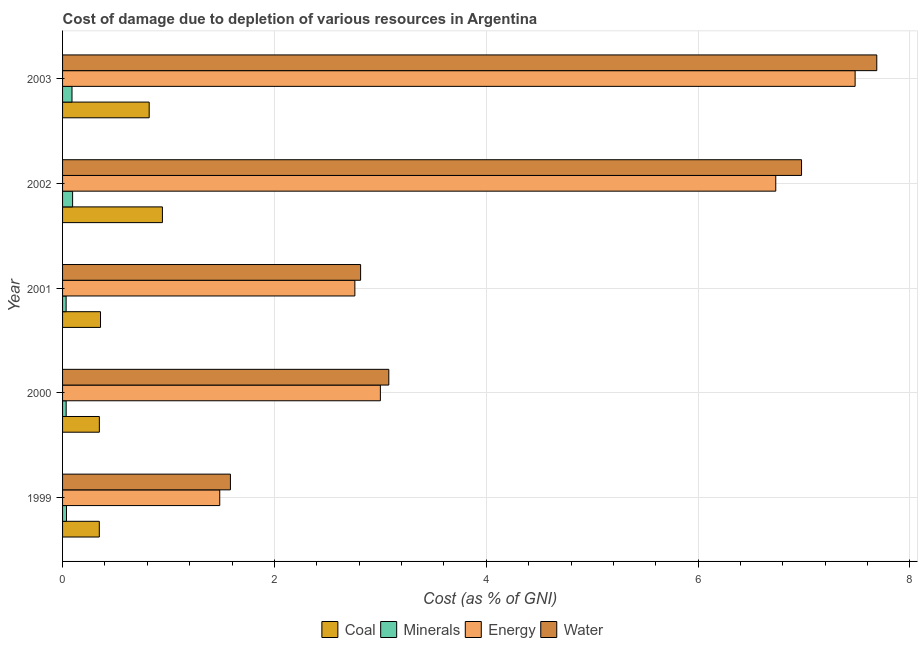How many different coloured bars are there?
Provide a succinct answer. 4. Are the number of bars per tick equal to the number of legend labels?
Provide a succinct answer. Yes. Are the number of bars on each tick of the Y-axis equal?
Ensure brevity in your answer.  Yes. What is the label of the 4th group of bars from the top?
Make the answer very short. 2000. In how many cases, is the number of bars for a given year not equal to the number of legend labels?
Your response must be concise. 0. What is the cost of damage due to depletion of coal in 2003?
Give a very brief answer. 0.82. Across all years, what is the maximum cost of damage due to depletion of water?
Offer a terse response. 7.69. Across all years, what is the minimum cost of damage due to depletion of energy?
Offer a terse response. 1.48. What is the total cost of damage due to depletion of water in the graph?
Provide a succinct answer. 22.14. What is the difference between the cost of damage due to depletion of coal in 1999 and that in 2000?
Your answer should be compact. -0. What is the difference between the cost of damage due to depletion of water in 1999 and the cost of damage due to depletion of energy in 2001?
Ensure brevity in your answer.  -1.17. What is the average cost of damage due to depletion of coal per year?
Make the answer very short. 0.56. In the year 2000, what is the difference between the cost of damage due to depletion of minerals and cost of damage due to depletion of energy?
Offer a terse response. -2.97. What is the ratio of the cost of damage due to depletion of energy in 2001 to that in 2002?
Your answer should be very brief. 0.41. Is the cost of damage due to depletion of energy in 1999 less than that in 2002?
Your answer should be compact. Yes. Is the difference between the cost of damage due to depletion of energy in 2000 and 2001 greater than the difference between the cost of damage due to depletion of minerals in 2000 and 2001?
Provide a succinct answer. Yes. What is the difference between the highest and the second highest cost of damage due to depletion of water?
Give a very brief answer. 0.71. In how many years, is the cost of damage due to depletion of coal greater than the average cost of damage due to depletion of coal taken over all years?
Ensure brevity in your answer.  2. Is it the case that in every year, the sum of the cost of damage due to depletion of water and cost of damage due to depletion of coal is greater than the sum of cost of damage due to depletion of minerals and cost of damage due to depletion of energy?
Provide a succinct answer. Yes. What does the 3rd bar from the top in 1999 represents?
Your answer should be compact. Minerals. What does the 3rd bar from the bottom in 2002 represents?
Your answer should be very brief. Energy. Is it the case that in every year, the sum of the cost of damage due to depletion of coal and cost of damage due to depletion of minerals is greater than the cost of damage due to depletion of energy?
Your response must be concise. No. How many bars are there?
Your response must be concise. 20. Are all the bars in the graph horizontal?
Keep it short and to the point. Yes. Does the graph contain grids?
Your response must be concise. Yes. Where does the legend appear in the graph?
Your answer should be compact. Bottom center. How are the legend labels stacked?
Offer a very short reply. Horizontal. What is the title of the graph?
Ensure brevity in your answer.  Cost of damage due to depletion of various resources in Argentina . What is the label or title of the X-axis?
Offer a terse response. Cost (as % of GNI). What is the Cost (as % of GNI) of Coal in 1999?
Your response must be concise. 0.35. What is the Cost (as % of GNI) of Minerals in 1999?
Keep it short and to the point. 0.04. What is the Cost (as % of GNI) of Energy in 1999?
Provide a succinct answer. 1.48. What is the Cost (as % of GNI) of Water in 1999?
Offer a terse response. 1.58. What is the Cost (as % of GNI) of Coal in 2000?
Offer a terse response. 0.35. What is the Cost (as % of GNI) in Minerals in 2000?
Provide a succinct answer. 0.03. What is the Cost (as % of GNI) of Energy in 2000?
Keep it short and to the point. 3. What is the Cost (as % of GNI) in Water in 2000?
Your answer should be compact. 3.08. What is the Cost (as % of GNI) of Coal in 2001?
Your response must be concise. 0.36. What is the Cost (as % of GNI) in Minerals in 2001?
Offer a very short reply. 0.03. What is the Cost (as % of GNI) in Energy in 2001?
Keep it short and to the point. 2.76. What is the Cost (as % of GNI) of Water in 2001?
Provide a short and direct response. 2.81. What is the Cost (as % of GNI) in Coal in 2002?
Keep it short and to the point. 0.94. What is the Cost (as % of GNI) in Minerals in 2002?
Your answer should be compact. 0.09. What is the Cost (as % of GNI) of Energy in 2002?
Provide a short and direct response. 6.73. What is the Cost (as % of GNI) in Water in 2002?
Your response must be concise. 6.98. What is the Cost (as % of GNI) of Coal in 2003?
Your answer should be very brief. 0.82. What is the Cost (as % of GNI) of Minerals in 2003?
Ensure brevity in your answer.  0.09. What is the Cost (as % of GNI) in Energy in 2003?
Your answer should be very brief. 7.48. What is the Cost (as % of GNI) of Water in 2003?
Make the answer very short. 7.69. Across all years, what is the maximum Cost (as % of GNI) in Coal?
Your answer should be compact. 0.94. Across all years, what is the maximum Cost (as % of GNI) of Minerals?
Provide a short and direct response. 0.09. Across all years, what is the maximum Cost (as % of GNI) of Energy?
Provide a short and direct response. 7.48. Across all years, what is the maximum Cost (as % of GNI) in Water?
Give a very brief answer. 7.69. Across all years, what is the minimum Cost (as % of GNI) in Coal?
Give a very brief answer. 0.35. Across all years, what is the minimum Cost (as % of GNI) of Minerals?
Make the answer very short. 0.03. Across all years, what is the minimum Cost (as % of GNI) in Energy?
Ensure brevity in your answer.  1.48. Across all years, what is the minimum Cost (as % of GNI) in Water?
Offer a terse response. 1.58. What is the total Cost (as % of GNI) in Coal in the graph?
Provide a succinct answer. 2.81. What is the total Cost (as % of GNI) of Minerals in the graph?
Offer a very short reply. 0.29. What is the total Cost (as % of GNI) in Energy in the graph?
Ensure brevity in your answer.  21.46. What is the total Cost (as % of GNI) in Water in the graph?
Ensure brevity in your answer.  22.14. What is the difference between the Cost (as % of GNI) of Coal in 1999 and that in 2000?
Make the answer very short. -0. What is the difference between the Cost (as % of GNI) in Minerals in 1999 and that in 2000?
Your answer should be very brief. 0. What is the difference between the Cost (as % of GNI) of Energy in 1999 and that in 2000?
Provide a succinct answer. -1.52. What is the difference between the Cost (as % of GNI) in Water in 1999 and that in 2000?
Your response must be concise. -1.5. What is the difference between the Cost (as % of GNI) in Coal in 1999 and that in 2001?
Provide a succinct answer. -0.01. What is the difference between the Cost (as % of GNI) of Minerals in 1999 and that in 2001?
Offer a very short reply. 0. What is the difference between the Cost (as % of GNI) of Energy in 1999 and that in 2001?
Keep it short and to the point. -1.28. What is the difference between the Cost (as % of GNI) in Water in 1999 and that in 2001?
Provide a short and direct response. -1.23. What is the difference between the Cost (as % of GNI) of Coal in 1999 and that in 2002?
Your answer should be compact. -0.6. What is the difference between the Cost (as % of GNI) of Minerals in 1999 and that in 2002?
Give a very brief answer. -0.06. What is the difference between the Cost (as % of GNI) in Energy in 1999 and that in 2002?
Provide a succinct answer. -5.25. What is the difference between the Cost (as % of GNI) of Water in 1999 and that in 2002?
Ensure brevity in your answer.  -5.39. What is the difference between the Cost (as % of GNI) in Coal in 1999 and that in 2003?
Your answer should be very brief. -0.47. What is the difference between the Cost (as % of GNI) in Minerals in 1999 and that in 2003?
Offer a terse response. -0.05. What is the difference between the Cost (as % of GNI) of Energy in 1999 and that in 2003?
Your response must be concise. -6. What is the difference between the Cost (as % of GNI) in Water in 1999 and that in 2003?
Offer a terse response. -6.1. What is the difference between the Cost (as % of GNI) of Coal in 2000 and that in 2001?
Provide a short and direct response. -0.01. What is the difference between the Cost (as % of GNI) of Minerals in 2000 and that in 2001?
Provide a short and direct response. 0. What is the difference between the Cost (as % of GNI) of Energy in 2000 and that in 2001?
Provide a short and direct response. 0.24. What is the difference between the Cost (as % of GNI) in Water in 2000 and that in 2001?
Provide a succinct answer. 0.27. What is the difference between the Cost (as % of GNI) of Coal in 2000 and that in 2002?
Your answer should be very brief. -0.6. What is the difference between the Cost (as % of GNI) in Minerals in 2000 and that in 2002?
Offer a terse response. -0.06. What is the difference between the Cost (as % of GNI) in Energy in 2000 and that in 2002?
Keep it short and to the point. -3.73. What is the difference between the Cost (as % of GNI) in Water in 2000 and that in 2002?
Ensure brevity in your answer.  -3.9. What is the difference between the Cost (as % of GNI) in Coal in 2000 and that in 2003?
Your answer should be compact. -0.47. What is the difference between the Cost (as % of GNI) of Minerals in 2000 and that in 2003?
Make the answer very short. -0.06. What is the difference between the Cost (as % of GNI) in Energy in 2000 and that in 2003?
Make the answer very short. -4.48. What is the difference between the Cost (as % of GNI) of Water in 2000 and that in 2003?
Offer a terse response. -4.61. What is the difference between the Cost (as % of GNI) in Coal in 2001 and that in 2002?
Make the answer very short. -0.58. What is the difference between the Cost (as % of GNI) of Minerals in 2001 and that in 2002?
Keep it short and to the point. -0.06. What is the difference between the Cost (as % of GNI) in Energy in 2001 and that in 2002?
Provide a succinct answer. -3.97. What is the difference between the Cost (as % of GNI) of Water in 2001 and that in 2002?
Your response must be concise. -4.16. What is the difference between the Cost (as % of GNI) in Coal in 2001 and that in 2003?
Keep it short and to the point. -0.46. What is the difference between the Cost (as % of GNI) of Minerals in 2001 and that in 2003?
Your answer should be compact. -0.06. What is the difference between the Cost (as % of GNI) of Energy in 2001 and that in 2003?
Your response must be concise. -4.72. What is the difference between the Cost (as % of GNI) in Water in 2001 and that in 2003?
Your answer should be compact. -4.87. What is the difference between the Cost (as % of GNI) of Coal in 2002 and that in 2003?
Your answer should be very brief. 0.12. What is the difference between the Cost (as % of GNI) in Minerals in 2002 and that in 2003?
Offer a terse response. 0.01. What is the difference between the Cost (as % of GNI) in Energy in 2002 and that in 2003?
Make the answer very short. -0.75. What is the difference between the Cost (as % of GNI) of Water in 2002 and that in 2003?
Ensure brevity in your answer.  -0.71. What is the difference between the Cost (as % of GNI) of Coal in 1999 and the Cost (as % of GNI) of Minerals in 2000?
Offer a very short reply. 0.31. What is the difference between the Cost (as % of GNI) of Coal in 1999 and the Cost (as % of GNI) of Energy in 2000?
Your answer should be very brief. -2.65. What is the difference between the Cost (as % of GNI) of Coal in 1999 and the Cost (as % of GNI) of Water in 2000?
Your answer should be compact. -2.73. What is the difference between the Cost (as % of GNI) of Minerals in 1999 and the Cost (as % of GNI) of Energy in 2000?
Offer a very short reply. -2.96. What is the difference between the Cost (as % of GNI) in Minerals in 1999 and the Cost (as % of GNI) in Water in 2000?
Give a very brief answer. -3.04. What is the difference between the Cost (as % of GNI) of Energy in 1999 and the Cost (as % of GNI) of Water in 2000?
Ensure brevity in your answer.  -1.6. What is the difference between the Cost (as % of GNI) of Coal in 1999 and the Cost (as % of GNI) of Minerals in 2001?
Keep it short and to the point. 0.31. What is the difference between the Cost (as % of GNI) in Coal in 1999 and the Cost (as % of GNI) in Energy in 2001?
Your answer should be compact. -2.41. What is the difference between the Cost (as % of GNI) of Coal in 1999 and the Cost (as % of GNI) of Water in 2001?
Ensure brevity in your answer.  -2.47. What is the difference between the Cost (as % of GNI) of Minerals in 1999 and the Cost (as % of GNI) of Energy in 2001?
Your answer should be compact. -2.72. What is the difference between the Cost (as % of GNI) of Minerals in 1999 and the Cost (as % of GNI) of Water in 2001?
Offer a very short reply. -2.78. What is the difference between the Cost (as % of GNI) of Energy in 1999 and the Cost (as % of GNI) of Water in 2001?
Offer a terse response. -1.33. What is the difference between the Cost (as % of GNI) of Coal in 1999 and the Cost (as % of GNI) of Minerals in 2002?
Provide a short and direct response. 0.25. What is the difference between the Cost (as % of GNI) of Coal in 1999 and the Cost (as % of GNI) of Energy in 2002?
Your response must be concise. -6.39. What is the difference between the Cost (as % of GNI) of Coal in 1999 and the Cost (as % of GNI) of Water in 2002?
Provide a succinct answer. -6.63. What is the difference between the Cost (as % of GNI) of Minerals in 1999 and the Cost (as % of GNI) of Energy in 2002?
Ensure brevity in your answer.  -6.7. What is the difference between the Cost (as % of GNI) of Minerals in 1999 and the Cost (as % of GNI) of Water in 2002?
Your answer should be compact. -6.94. What is the difference between the Cost (as % of GNI) of Energy in 1999 and the Cost (as % of GNI) of Water in 2002?
Provide a short and direct response. -5.49. What is the difference between the Cost (as % of GNI) of Coal in 1999 and the Cost (as % of GNI) of Minerals in 2003?
Offer a very short reply. 0.26. What is the difference between the Cost (as % of GNI) of Coal in 1999 and the Cost (as % of GNI) of Energy in 2003?
Keep it short and to the point. -7.14. What is the difference between the Cost (as % of GNI) of Coal in 1999 and the Cost (as % of GNI) of Water in 2003?
Offer a very short reply. -7.34. What is the difference between the Cost (as % of GNI) in Minerals in 1999 and the Cost (as % of GNI) in Energy in 2003?
Offer a very short reply. -7.44. What is the difference between the Cost (as % of GNI) in Minerals in 1999 and the Cost (as % of GNI) in Water in 2003?
Offer a very short reply. -7.65. What is the difference between the Cost (as % of GNI) of Energy in 1999 and the Cost (as % of GNI) of Water in 2003?
Your answer should be very brief. -6.2. What is the difference between the Cost (as % of GNI) of Coal in 2000 and the Cost (as % of GNI) of Minerals in 2001?
Provide a short and direct response. 0.31. What is the difference between the Cost (as % of GNI) in Coal in 2000 and the Cost (as % of GNI) in Energy in 2001?
Make the answer very short. -2.41. What is the difference between the Cost (as % of GNI) in Coal in 2000 and the Cost (as % of GNI) in Water in 2001?
Ensure brevity in your answer.  -2.47. What is the difference between the Cost (as % of GNI) in Minerals in 2000 and the Cost (as % of GNI) in Energy in 2001?
Your answer should be compact. -2.73. What is the difference between the Cost (as % of GNI) in Minerals in 2000 and the Cost (as % of GNI) in Water in 2001?
Offer a terse response. -2.78. What is the difference between the Cost (as % of GNI) of Energy in 2000 and the Cost (as % of GNI) of Water in 2001?
Provide a short and direct response. 0.19. What is the difference between the Cost (as % of GNI) of Coal in 2000 and the Cost (as % of GNI) of Minerals in 2002?
Your answer should be compact. 0.25. What is the difference between the Cost (as % of GNI) in Coal in 2000 and the Cost (as % of GNI) in Energy in 2002?
Keep it short and to the point. -6.39. What is the difference between the Cost (as % of GNI) in Coal in 2000 and the Cost (as % of GNI) in Water in 2002?
Offer a terse response. -6.63. What is the difference between the Cost (as % of GNI) in Minerals in 2000 and the Cost (as % of GNI) in Energy in 2002?
Keep it short and to the point. -6.7. What is the difference between the Cost (as % of GNI) of Minerals in 2000 and the Cost (as % of GNI) of Water in 2002?
Make the answer very short. -6.94. What is the difference between the Cost (as % of GNI) of Energy in 2000 and the Cost (as % of GNI) of Water in 2002?
Ensure brevity in your answer.  -3.98. What is the difference between the Cost (as % of GNI) of Coal in 2000 and the Cost (as % of GNI) of Minerals in 2003?
Provide a short and direct response. 0.26. What is the difference between the Cost (as % of GNI) in Coal in 2000 and the Cost (as % of GNI) in Energy in 2003?
Ensure brevity in your answer.  -7.13. What is the difference between the Cost (as % of GNI) in Coal in 2000 and the Cost (as % of GNI) in Water in 2003?
Offer a terse response. -7.34. What is the difference between the Cost (as % of GNI) in Minerals in 2000 and the Cost (as % of GNI) in Energy in 2003?
Provide a succinct answer. -7.45. What is the difference between the Cost (as % of GNI) of Minerals in 2000 and the Cost (as % of GNI) of Water in 2003?
Offer a very short reply. -7.65. What is the difference between the Cost (as % of GNI) of Energy in 2000 and the Cost (as % of GNI) of Water in 2003?
Provide a succinct answer. -4.69. What is the difference between the Cost (as % of GNI) of Coal in 2001 and the Cost (as % of GNI) of Minerals in 2002?
Your answer should be compact. 0.26. What is the difference between the Cost (as % of GNI) of Coal in 2001 and the Cost (as % of GNI) of Energy in 2002?
Offer a very short reply. -6.37. What is the difference between the Cost (as % of GNI) of Coal in 2001 and the Cost (as % of GNI) of Water in 2002?
Make the answer very short. -6.62. What is the difference between the Cost (as % of GNI) of Minerals in 2001 and the Cost (as % of GNI) of Energy in 2002?
Your response must be concise. -6.7. What is the difference between the Cost (as % of GNI) in Minerals in 2001 and the Cost (as % of GNI) in Water in 2002?
Offer a terse response. -6.94. What is the difference between the Cost (as % of GNI) in Energy in 2001 and the Cost (as % of GNI) in Water in 2002?
Offer a terse response. -4.22. What is the difference between the Cost (as % of GNI) of Coal in 2001 and the Cost (as % of GNI) of Minerals in 2003?
Your answer should be very brief. 0.27. What is the difference between the Cost (as % of GNI) of Coal in 2001 and the Cost (as % of GNI) of Energy in 2003?
Ensure brevity in your answer.  -7.12. What is the difference between the Cost (as % of GNI) of Coal in 2001 and the Cost (as % of GNI) of Water in 2003?
Make the answer very short. -7.33. What is the difference between the Cost (as % of GNI) in Minerals in 2001 and the Cost (as % of GNI) in Energy in 2003?
Offer a terse response. -7.45. What is the difference between the Cost (as % of GNI) in Minerals in 2001 and the Cost (as % of GNI) in Water in 2003?
Your response must be concise. -7.65. What is the difference between the Cost (as % of GNI) of Energy in 2001 and the Cost (as % of GNI) of Water in 2003?
Give a very brief answer. -4.93. What is the difference between the Cost (as % of GNI) in Coal in 2002 and the Cost (as % of GNI) in Minerals in 2003?
Provide a succinct answer. 0.85. What is the difference between the Cost (as % of GNI) in Coal in 2002 and the Cost (as % of GNI) in Energy in 2003?
Offer a very short reply. -6.54. What is the difference between the Cost (as % of GNI) of Coal in 2002 and the Cost (as % of GNI) of Water in 2003?
Your answer should be compact. -6.74. What is the difference between the Cost (as % of GNI) of Minerals in 2002 and the Cost (as % of GNI) of Energy in 2003?
Offer a terse response. -7.39. What is the difference between the Cost (as % of GNI) of Minerals in 2002 and the Cost (as % of GNI) of Water in 2003?
Ensure brevity in your answer.  -7.59. What is the difference between the Cost (as % of GNI) in Energy in 2002 and the Cost (as % of GNI) in Water in 2003?
Your answer should be very brief. -0.95. What is the average Cost (as % of GNI) in Coal per year?
Provide a short and direct response. 0.56. What is the average Cost (as % of GNI) of Minerals per year?
Keep it short and to the point. 0.06. What is the average Cost (as % of GNI) of Energy per year?
Give a very brief answer. 4.29. What is the average Cost (as % of GNI) of Water per year?
Your answer should be very brief. 4.43. In the year 1999, what is the difference between the Cost (as % of GNI) of Coal and Cost (as % of GNI) of Minerals?
Offer a terse response. 0.31. In the year 1999, what is the difference between the Cost (as % of GNI) in Coal and Cost (as % of GNI) in Energy?
Your answer should be very brief. -1.14. In the year 1999, what is the difference between the Cost (as % of GNI) of Coal and Cost (as % of GNI) of Water?
Give a very brief answer. -1.24. In the year 1999, what is the difference between the Cost (as % of GNI) of Minerals and Cost (as % of GNI) of Energy?
Your response must be concise. -1.45. In the year 1999, what is the difference between the Cost (as % of GNI) of Minerals and Cost (as % of GNI) of Water?
Offer a very short reply. -1.55. In the year 1999, what is the difference between the Cost (as % of GNI) of Energy and Cost (as % of GNI) of Water?
Your answer should be very brief. -0.1. In the year 2000, what is the difference between the Cost (as % of GNI) in Coal and Cost (as % of GNI) in Minerals?
Provide a succinct answer. 0.31. In the year 2000, what is the difference between the Cost (as % of GNI) of Coal and Cost (as % of GNI) of Energy?
Ensure brevity in your answer.  -2.65. In the year 2000, what is the difference between the Cost (as % of GNI) of Coal and Cost (as % of GNI) of Water?
Provide a succinct answer. -2.73. In the year 2000, what is the difference between the Cost (as % of GNI) of Minerals and Cost (as % of GNI) of Energy?
Make the answer very short. -2.97. In the year 2000, what is the difference between the Cost (as % of GNI) of Minerals and Cost (as % of GNI) of Water?
Your answer should be very brief. -3.05. In the year 2000, what is the difference between the Cost (as % of GNI) of Energy and Cost (as % of GNI) of Water?
Your answer should be very brief. -0.08. In the year 2001, what is the difference between the Cost (as % of GNI) in Coal and Cost (as % of GNI) in Minerals?
Provide a short and direct response. 0.32. In the year 2001, what is the difference between the Cost (as % of GNI) of Coal and Cost (as % of GNI) of Energy?
Ensure brevity in your answer.  -2.4. In the year 2001, what is the difference between the Cost (as % of GNI) in Coal and Cost (as % of GNI) in Water?
Give a very brief answer. -2.46. In the year 2001, what is the difference between the Cost (as % of GNI) of Minerals and Cost (as % of GNI) of Energy?
Provide a succinct answer. -2.73. In the year 2001, what is the difference between the Cost (as % of GNI) of Minerals and Cost (as % of GNI) of Water?
Your answer should be very brief. -2.78. In the year 2001, what is the difference between the Cost (as % of GNI) in Energy and Cost (as % of GNI) in Water?
Make the answer very short. -0.05. In the year 2002, what is the difference between the Cost (as % of GNI) of Coal and Cost (as % of GNI) of Minerals?
Make the answer very short. 0.85. In the year 2002, what is the difference between the Cost (as % of GNI) in Coal and Cost (as % of GNI) in Energy?
Offer a terse response. -5.79. In the year 2002, what is the difference between the Cost (as % of GNI) in Coal and Cost (as % of GNI) in Water?
Offer a very short reply. -6.03. In the year 2002, what is the difference between the Cost (as % of GNI) of Minerals and Cost (as % of GNI) of Energy?
Offer a very short reply. -6.64. In the year 2002, what is the difference between the Cost (as % of GNI) in Minerals and Cost (as % of GNI) in Water?
Keep it short and to the point. -6.88. In the year 2002, what is the difference between the Cost (as % of GNI) of Energy and Cost (as % of GNI) of Water?
Your answer should be very brief. -0.24. In the year 2003, what is the difference between the Cost (as % of GNI) of Coal and Cost (as % of GNI) of Minerals?
Offer a terse response. 0.73. In the year 2003, what is the difference between the Cost (as % of GNI) of Coal and Cost (as % of GNI) of Energy?
Offer a very short reply. -6.66. In the year 2003, what is the difference between the Cost (as % of GNI) of Coal and Cost (as % of GNI) of Water?
Make the answer very short. -6.87. In the year 2003, what is the difference between the Cost (as % of GNI) in Minerals and Cost (as % of GNI) in Energy?
Ensure brevity in your answer.  -7.39. In the year 2003, what is the difference between the Cost (as % of GNI) of Minerals and Cost (as % of GNI) of Water?
Keep it short and to the point. -7.6. In the year 2003, what is the difference between the Cost (as % of GNI) of Energy and Cost (as % of GNI) of Water?
Provide a short and direct response. -0.2. What is the ratio of the Cost (as % of GNI) of Minerals in 1999 to that in 2000?
Offer a terse response. 1.09. What is the ratio of the Cost (as % of GNI) of Energy in 1999 to that in 2000?
Your answer should be compact. 0.49. What is the ratio of the Cost (as % of GNI) in Water in 1999 to that in 2000?
Make the answer very short. 0.51. What is the ratio of the Cost (as % of GNI) of Coal in 1999 to that in 2001?
Ensure brevity in your answer.  0.97. What is the ratio of the Cost (as % of GNI) in Minerals in 1999 to that in 2001?
Make the answer very short. 1.11. What is the ratio of the Cost (as % of GNI) of Energy in 1999 to that in 2001?
Your answer should be compact. 0.54. What is the ratio of the Cost (as % of GNI) in Water in 1999 to that in 2001?
Provide a short and direct response. 0.56. What is the ratio of the Cost (as % of GNI) of Coal in 1999 to that in 2002?
Provide a short and direct response. 0.37. What is the ratio of the Cost (as % of GNI) in Minerals in 1999 to that in 2002?
Give a very brief answer. 0.39. What is the ratio of the Cost (as % of GNI) of Energy in 1999 to that in 2002?
Ensure brevity in your answer.  0.22. What is the ratio of the Cost (as % of GNI) of Water in 1999 to that in 2002?
Ensure brevity in your answer.  0.23. What is the ratio of the Cost (as % of GNI) in Coal in 1999 to that in 2003?
Your answer should be very brief. 0.42. What is the ratio of the Cost (as % of GNI) of Minerals in 1999 to that in 2003?
Make the answer very short. 0.42. What is the ratio of the Cost (as % of GNI) in Energy in 1999 to that in 2003?
Provide a succinct answer. 0.2. What is the ratio of the Cost (as % of GNI) in Water in 1999 to that in 2003?
Keep it short and to the point. 0.21. What is the ratio of the Cost (as % of GNI) in Coal in 2000 to that in 2001?
Provide a short and direct response. 0.97. What is the ratio of the Cost (as % of GNI) of Minerals in 2000 to that in 2001?
Provide a succinct answer. 1.01. What is the ratio of the Cost (as % of GNI) in Energy in 2000 to that in 2001?
Give a very brief answer. 1.09. What is the ratio of the Cost (as % of GNI) of Water in 2000 to that in 2001?
Your answer should be compact. 1.09. What is the ratio of the Cost (as % of GNI) in Coal in 2000 to that in 2002?
Make the answer very short. 0.37. What is the ratio of the Cost (as % of GNI) of Minerals in 2000 to that in 2002?
Your answer should be compact. 0.36. What is the ratio of the Cost (as % of GNI) of Energy in 2000 to that in 2002?
Your response must be concise. 0.45. What is the ratio of the Cost (as % of GNI) in Water in 2000 to that in 2002?
Offer a terse response. 0.44. What is the ratio of the Cost (as % of GNI) in Coal in 2000 to that in 2003?
Offer a terse response. 0.42. What is the ratio of the Cost (as % of GNI) in Minerals in 2000 to that in 2003?
Provide a succinct answer. 0.38. What is the ratio of the Cost (as % of GNI) of Energy in 2000 to that in 2003?
Offer a very short reply. 0.4. What is the ratio of the Cost (as % of GNI) of Water in 2000 to that in 2003?
Give a very brief answer. 0.4. What is the ratio of the Cost (as % of GNI) of Coal in 2001 to that in 2002?
Ensure brevity in your answer.  0.38. What is the ratio of the Cost (as % of GNI) of Minerals in 2001 to that in 2002?
Give a very brief answer. 0.35. What is the ratio of the Cost (as % of GNI) in Energy in 2001 to that in 2002?
Provide a short and direct response. 0.41. What is the ratio of the Cost (as % of GNI) in Water in 2001 to that in 2002?
Make the answer very short. 0.4. What is the ratio of the Cost (as % of GNI) in Coal in 2001 to that in 2003?
Your response must be concise. 0.44. What is the ratio of the Cost (as % of GNI) in Minerals in 2001 to that in 2003?
Give a very brief answer. 0.38. What is the ratio of the Cost (as % of GNI) in Energy in 2001 to that in 2003?
Your response must be concise. 0.37. What is the ratio of the Cost (as % of GNI) in Water in 2001 to that in 2003?
Provide a short and direct response. 0.37. What is the ratio of the Cost (as % of GNI) in Coal in 2002 to that in 2003?
Your answer should be very brief. 1.15. What is the ratio of the Cost (as % of GNI) of Minerals in 2002 to that in 2003?
Offer a very short reply. 1.06. What is the ratio of the Cost (as % of GNI) of Energy in 2002 to that in 2003?
Ensure brevity in your answer.  0.9. What is the ratio of the Cost (as % of GNI) in Water in 2002 to that in 2003?
Offer a very short reply. 0.91. What is the difference between the highest and the second highest Cost (as % of GNI) of Minerals?
Your answer should be compact. 0.01. What is the difference between the highest and the second highest Cost (as % of GNI) in Energy?
Provide a short and direct response. 0.75. What is the difference between the highest and the second highest Cost (as % of GNI) of Water?
Offer a terse response. 0.71. What is the difference between the highest and the lowest Cost (as % of GNI) of Coal?
Keep it short and to the point. 0.6. What is the difference between the highest and the lowest Cost (as % of GNI) in Minerals?
Give a very brief answer. 0.06. What is the difference between the highest and the lowest Cost (as % of GNI) in Energy?
Offer a terse response. 6. What is the difference between the highest and the lowest Cost (as % of GNI) of Water?
Keep it short and to the point. 6.1. 